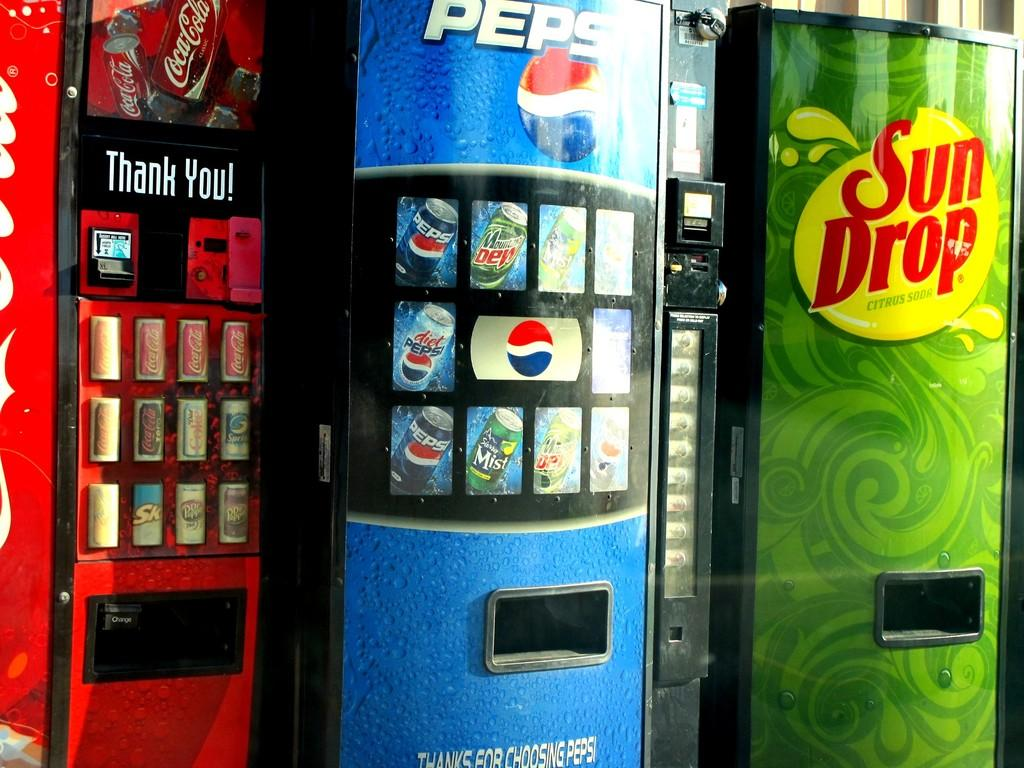<image>
Write a terse but informative summary of the picture. Coca-Cola, Pepsi, and Sun Drop vending machines are next to each other. 